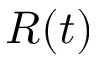<formula> <loc_0><loc_0><loc_500><loc_500>R ( t )</formula> 